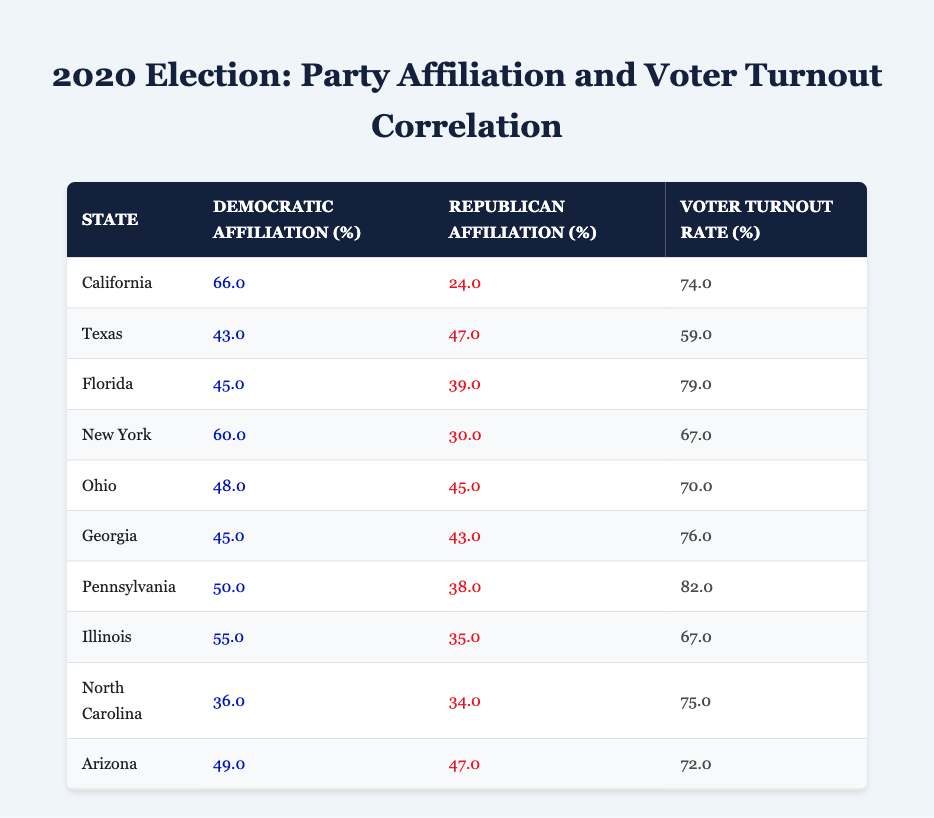What is the voter turnout rate for California? The voter turnout rate for California can be found directly in the table under the "Voter Turnout Rate (%)" column for California. The value listed is 74.0.
Answer: 74.0 Which state has the highest voter turnout rate? To find the state with the highest voter turnout rate, we compare all values in the "Voter Turnout Rate (%)" column. Pennsylvania has the highest value at 82.0.
Answer: Pennsylvania What is the difference in democratic affiliation percentage between Texas and Florida? We look at the democratic affiliation percentages for Texas (43.0) and Florida (45.0), then subtract: 45.0 - 43.0 = 2.0.
Answer: 2.0 Is the voter turnout rate for New York greater than 70%? The voter turnout rate for New York is 67.0, which is less than 70%. Therefore, this statement is false.
Answer: No What is the average voter turnout rate for all states listed in the table? To find the average, we add all the voter turnout rates: 74.0 + 59.0 + 79.0 + 67.0 + 70.0 + 76.0 + 82.0 + 67.0 + 75.0 + 72.0 =  750.0. There are 10 states, so the average is 750.0 / 10 = 75.0.
Answer: 75.0 Which state has a higher republican affiliation percentage, Ohio or Georgia? The republican affiliation percentage for Ohio is 45.0, while for Georgia, it is 43.0. Since 45.0 is greater than 43.0, Ohio has a higher republican affiliation percentage.
Answer: Ohio Are there more states with a democratic affiliation percentage greater than 50% or less than 50%? By examining the "Democratic Affiliation (%)" column, we find that California, New York, Pennsylvania, and Illinois have percentages greater than 50%, totaling 4 states. The other states (Texas, Florida, Ohio, Georgia, North Carolina, and Arizona) have percentages less than 50%, totaling 6 states. Since 6 is greater than 4, there are more states below 50%.
Answer: No What percentage of states have a voter turnout rate of 75% or higher? The states with a voter turnout rate of 75% or higher are California (74.0), Florida (79.0), Pennsylvania (82.0), Georgia (76.0), and North Carolina (75.0), totaling 5 out of 10 states. Therefore, the percentage is (5 / 10) * 100 = 50%.
Answer: 50% 